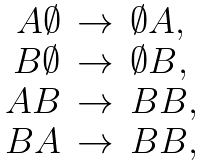Convert formula to latex. <formula><loc_0><loc_0><loc_500><loc_500>\begin{array} { r c l } A \emptyset & \rightarrow & \emptyset A , \\ B \emptyset & \rightarrow & \emptyset B , \\ A B & \rightarrow & B B , \\ B A & \rightarrow & B B , \end{array}</formula> 